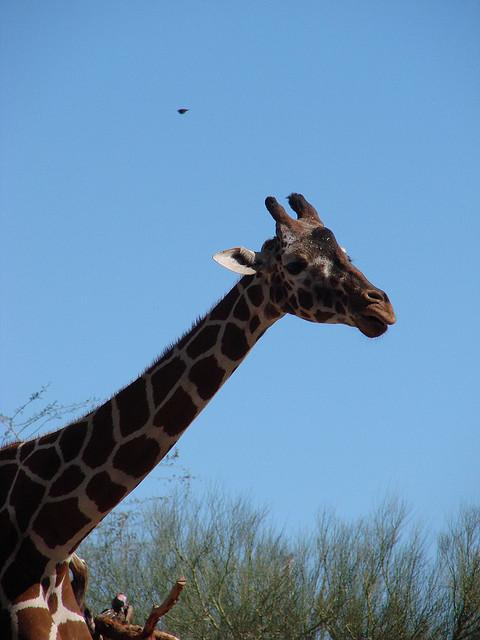How many giraffes can be seen?
Write a very short answer. 1. What is above the giraffe?
Give a very brief answer. Bird. What is the predominant color of this animal's fur?
Keep it brief. Brown. What is the giraffe doing near the forest?
Quick response, please. Standing. 